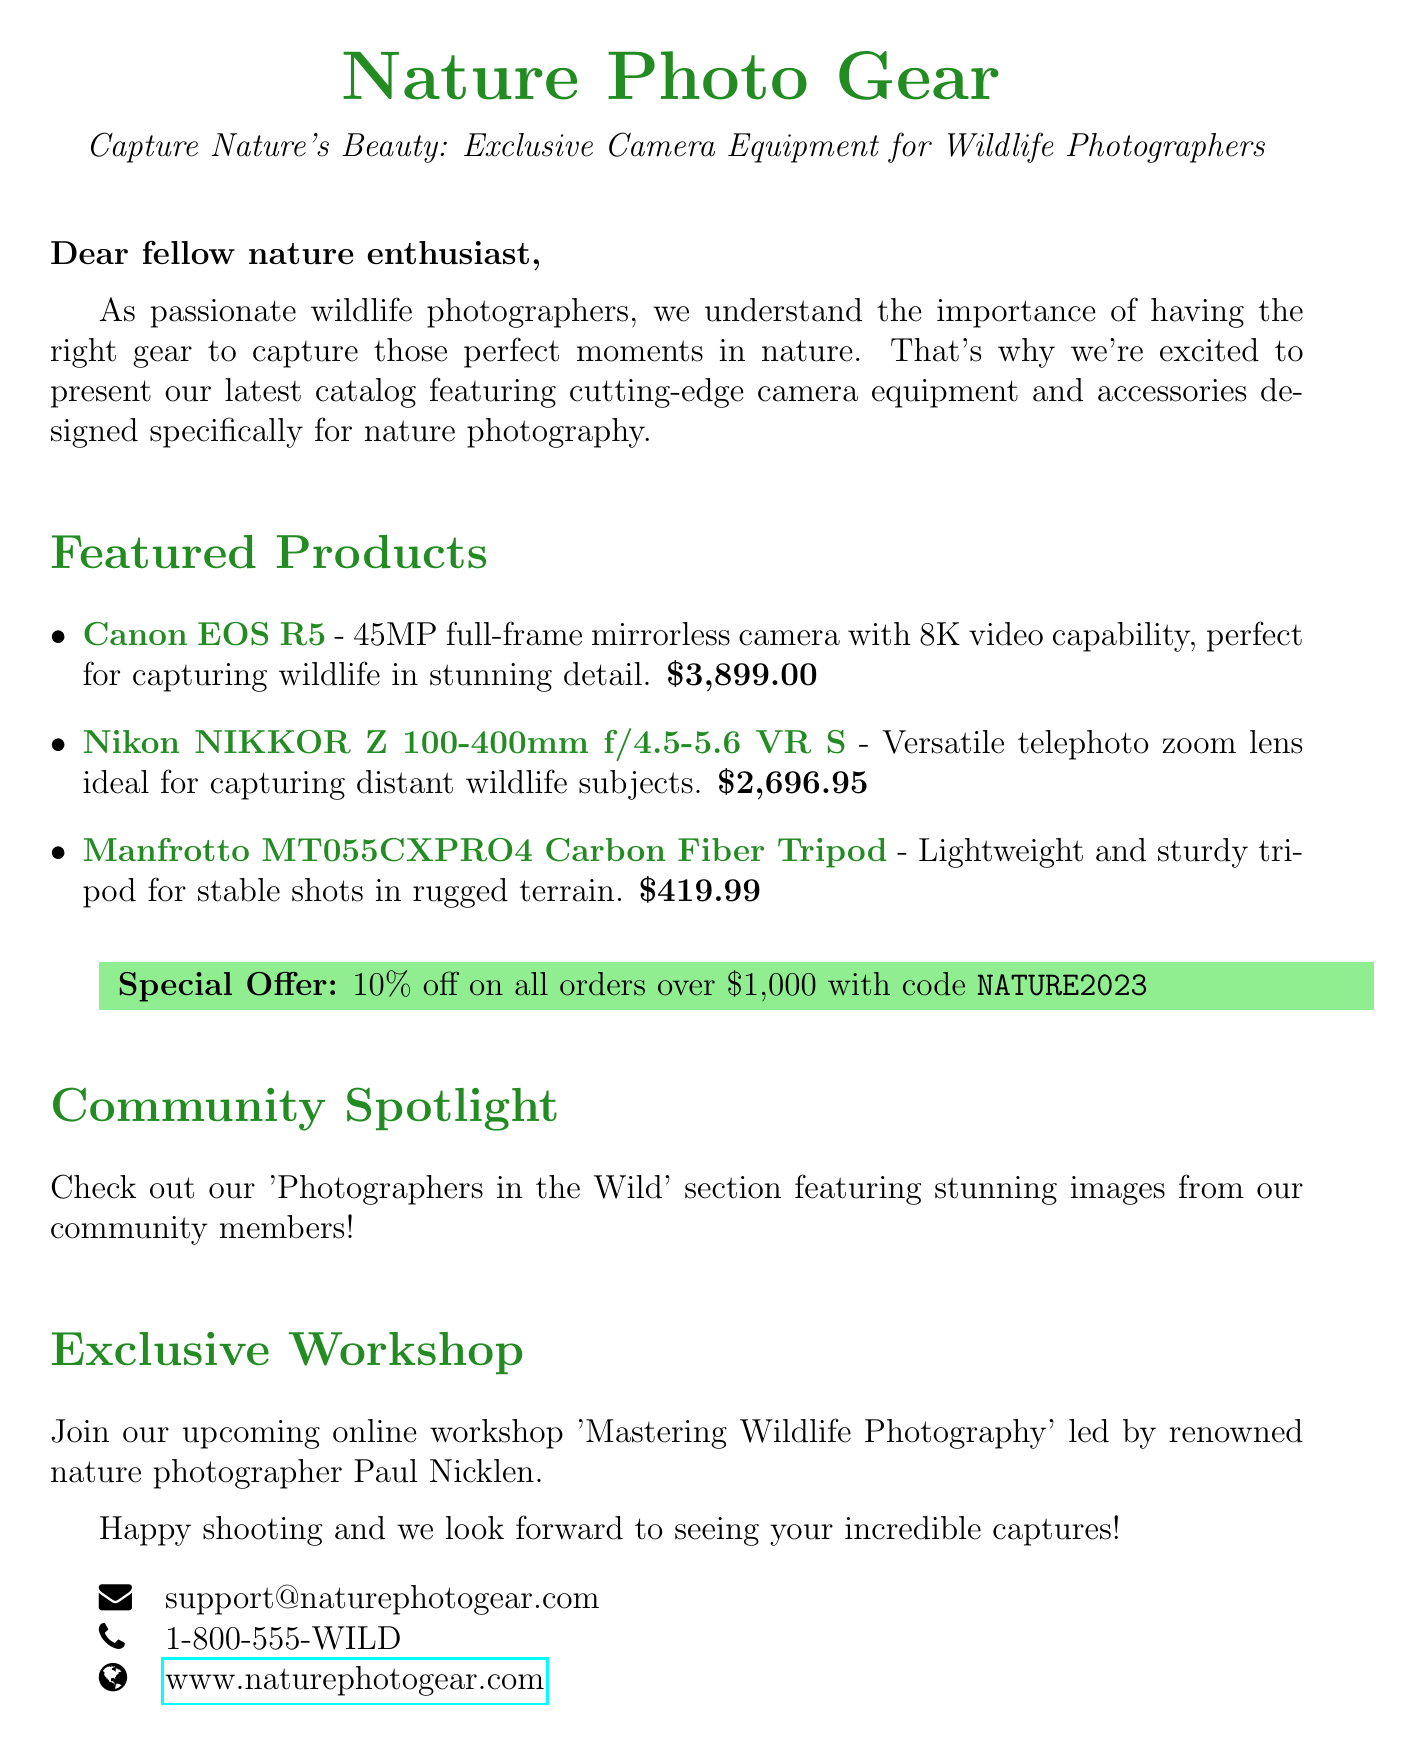What is the subject of the email? The subject of the email is explicitly mentioned at the beginning of the document.
Answer: Capture Nature's Beauty: Exclusive Camera Equipment for Wildlife Photographers What is the price of the Canon EOS R5? The price is listed next to the product description in the featured products section.
Answer: $3,899.00 What discount code is provided for orders over $1,000? The discount code is specified under the special offer section.
Answer: NATURE2023 Who is leading the online workshop? The document mentions the name of the photographer leading the workshop in the exclusive workshop section.
Answer: Paul Nicklen What type of lens is the Nikon NIKKOR Z 100-400mm? The lens type is described in the feature information about the product.
Answer: Telephoto zoom lens What is the main purpose of the catalog? The introduction outlines the main purpose of the catalog as it relates to wildlife photographers.
Answer: To showcase camera equipment and accessories for nature photography What is featured in the 'Photographers in the Wild' section? The community spotlight explains what can be found in this section.
Answer: Stunning images from community members What is the price of the Manfrotto MT055CXPRO4 Carbon Fiber Tripod? The price is mentioned alongside the description of the tripod in the featured products section.
Answer: $419.99 